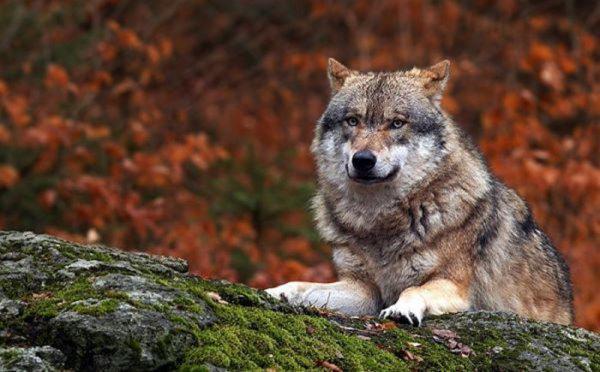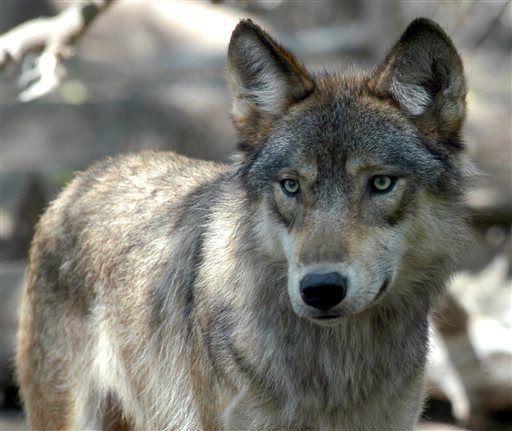The first image is the image on the left, the second image is the image on the right. Assess this claim about the two images: "The wolf in the image on the left is in front of red foliage.". Correct or not? Answer yes or no. Yes. 